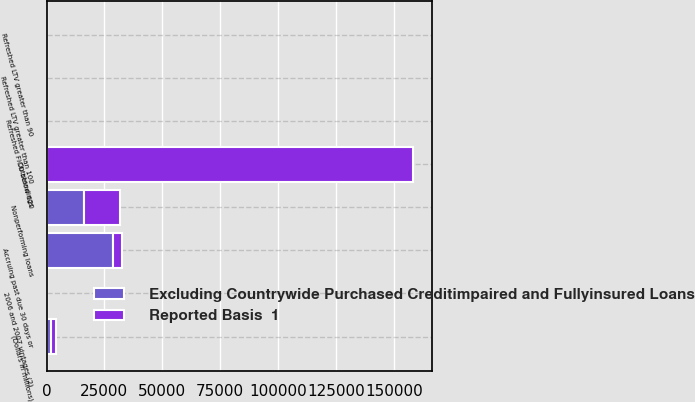<chart> <loc_0><loc_0><loc_500><loc_500><stacked_bar_chart><ecel><fcel>(Dollars in millions)<fcel>Outstandings<fcel>Accruing past due 30 days or<fcel>Nonperforming loans<fcel>Refreshed LTV greater than 90<fcel>Refreshed LTV greater than 100<fcel>Refreshed FICO below 620<fcel>2006 and 2007 vintages (2)<nl><fcel>Excluding Countrywide Purchased Creditimpaired and Fullyinsured Loans<fcel>2011<fcel>37<fcel>28688<fcel>15970<fcel>15<fcel>33<fcel>21<fcel>27<nl><fcel>Reported Basis  1<fcel>2011<fcel>158470<fcel>3950<fcel>15970<fcel>11<fcel>26<fcel>15<fcel>37<nl></chart> 